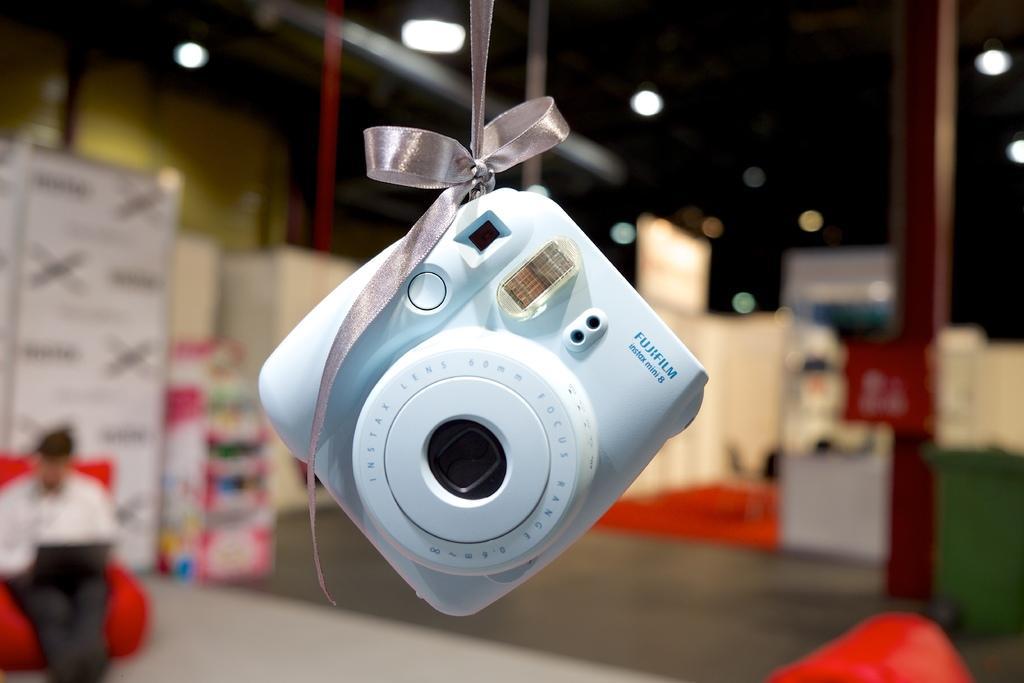How would you summarize this image in a sentence or two? In the picture we can see a camera tied with a ribbon to the ceiling and behind it, we can see a man sitting on the chair and behind him we can see some things are placed which are not clearly visible. 